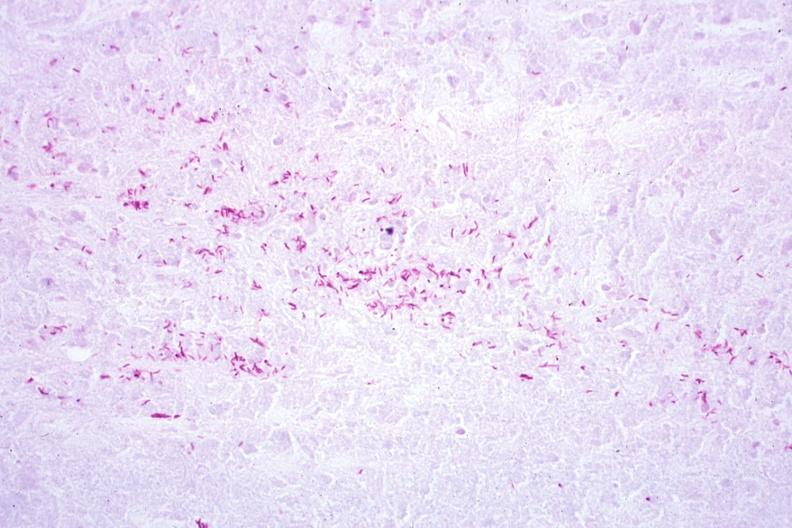s lymph node present?
Answer the question using a single word or phrase. Yes 